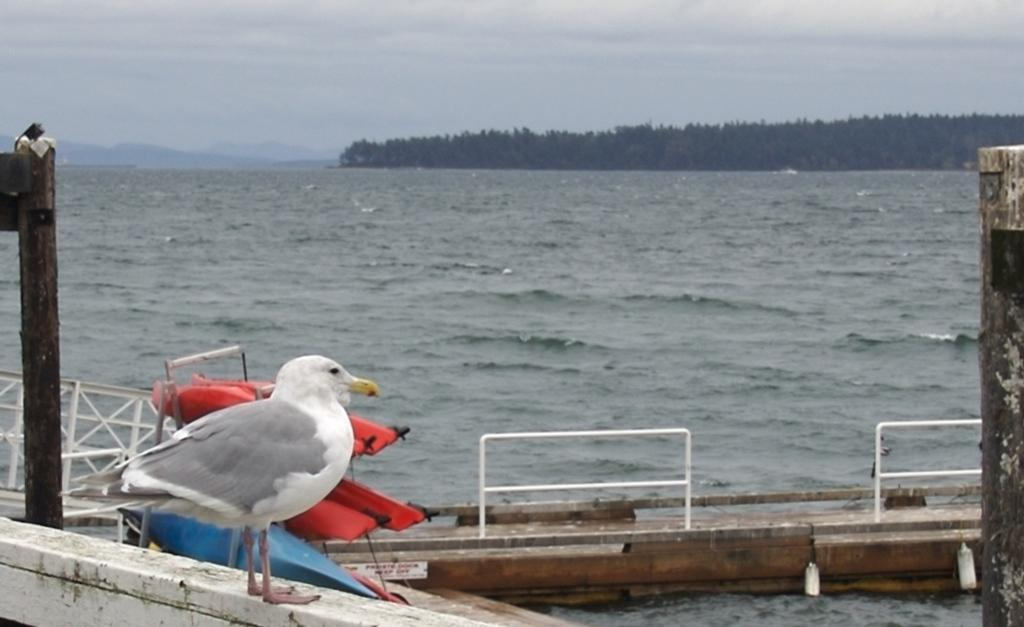What type of bird can be seen in the image? There is a seagull in the image. What is the primary element visible in the image? Water is visible in the image. What architectural feature can be seen in the image? There are railings in the image. What type of natural scenery is visible in the background of the image? Trees, hills, and the sky are visible in the background of the image. What type of learning is taking place in the image? There is no learning taking place in the image; it features a seagull and other natural elements. What type of protest is depicted in the image? There is no protest depicted in the image; it features a seagull and other natural elements. 